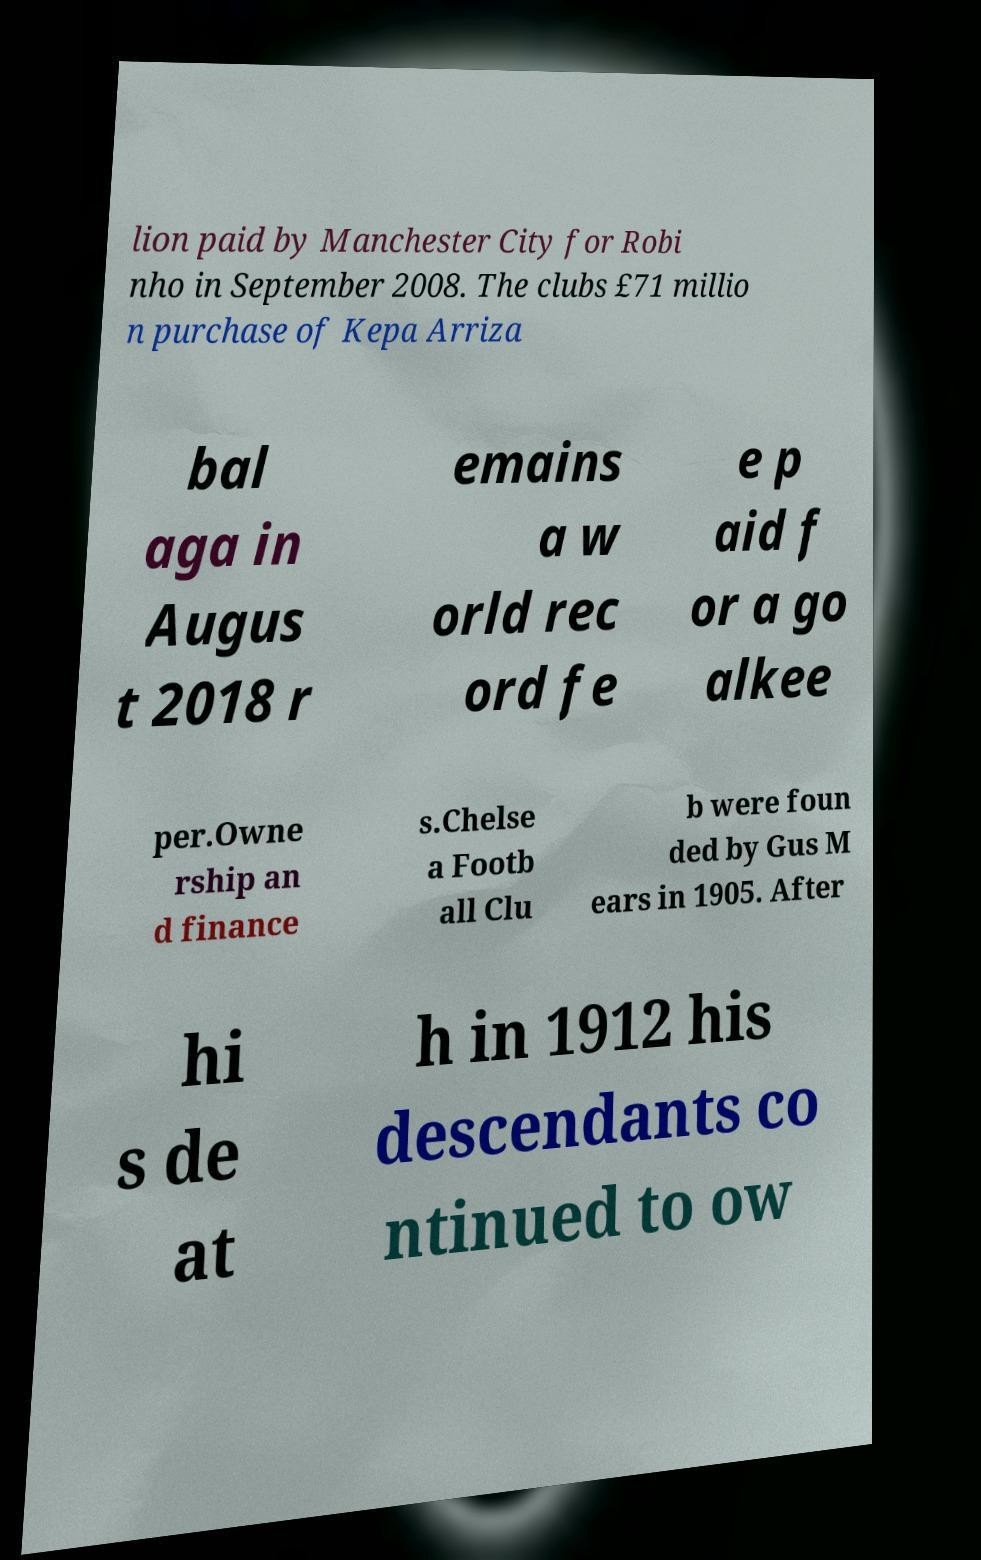What messages or text are displayed in this image? I need them in a readable, typed format. lion paid by Manchester City for Robi nho in September 2008. The clubs £71 millio n purchase of Kepa Arriza bal aga in Augus t 2018 r emains a w orld rec ord fe e p aid f or a go alkee per.Owne rship an d finance s.Chelse a Footb all Clu b were foun ded by Gus M ears in 1905. After hi s de at h in 1912 his descendants co ntinued to ow 